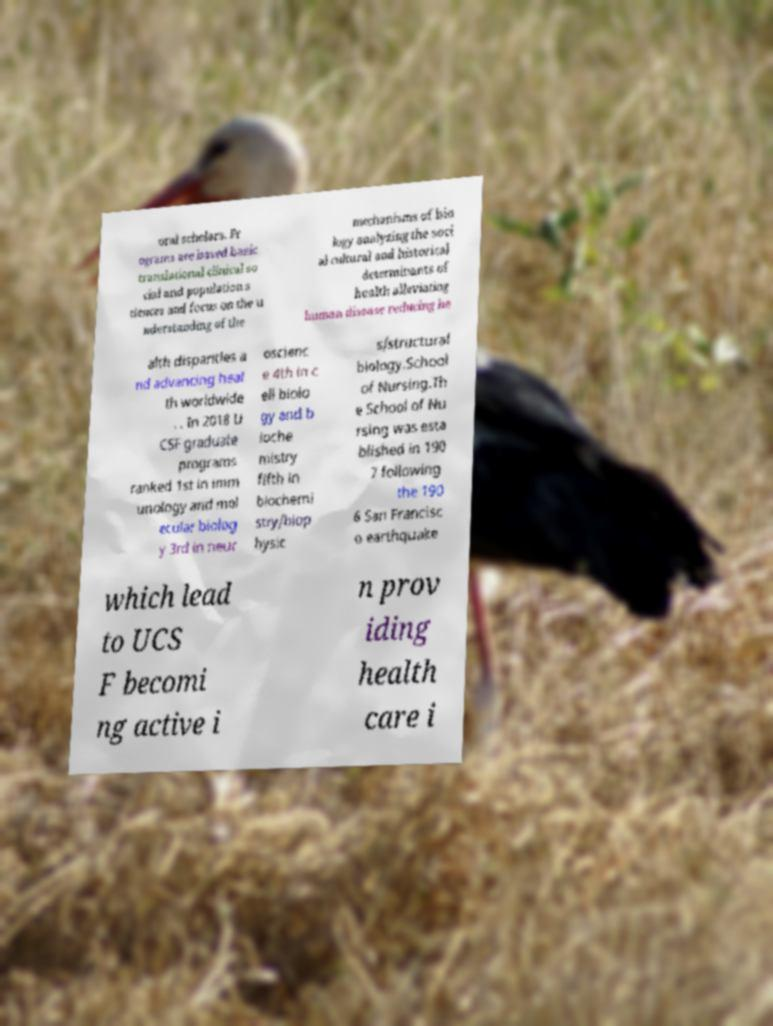Could you assist in decoding the text presented in this image and type it out clearly? oral scholars. Pr ograms are based basic translational clinical so cial and population s ciences and focus on the u nderstanding of the mechanisms of bio logy analyzing the soci al cultural and historical determinants of health alleviating human disease reducing he alth disparities a nd advancing heal th worldwide . . In 2018 U CSF graduate programs ranked 1st in imm unology and mol ecular biolog y 3rd in neur oscienc e 4th in c ell biolo gy and b ioche mistry fifth in biochemi stry/biop hysic s/structural biology.School of Nursing.Th e School of Nu rsing was esta blished in 190 7 following the 190 6 San Francisc o earthquake which lead to UCS F becomi ng active i n prov iding health care i 